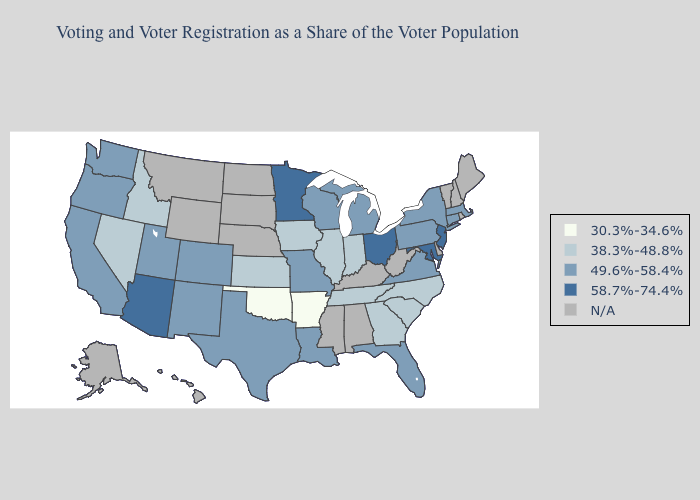Does Maryland have the lowest value in the South?
Short answer required. No. Name the states that have a value in the range 49.6%-58.4%?
Quick response, please. California, Colorado, Connecticut, Florida, Louisiana, Massachusetts, Michigan, Missouri, New Mexico, New York, Oregon, Pennsylvania, Texas, Utah, Virginia, Washington, Wisconsin. Name the states that have a value in the range 49.6%-58.4%?
Concise answer only. California, Colorado, Connecticut, Florida, Louisiana, Massachusetts, Michigan, Missouri, New Mexico, New York, Oregon, Pennsylvania, Texas, Utah, Virginia, Washington, Wisconsin. What is the value of North Dakota?
Answer briefly. N/A. Which states have the highest value in the USA?
Quick response, please. Arizona, Maryland, Minnesota, New Jersey, Ohio. Does the map have missing data?
Write a very short answer. Yes. What is the lowest value in states that border Florida?
Concise answer only. 38.3%-48.8%. What is the value of New York?
Quick response, please. 49.6%-58.4%. Name the states that have a value in the range 30.3%-34.6%?
Keep it brief. Arkansas, Oklahoma. What is the highest value in states that border Arizona?
Keep it brief. 49.6%-58.4%. Does Louisiana have the lowest value in the USA?
Give a very brief answer. No. Which states have the highest value in the USA?
Write a very short answer. Arizona, Maryland, Minnesota, New Jersey, Ohio. What is the value of Hawaii?
Answer briefly. N/A. 